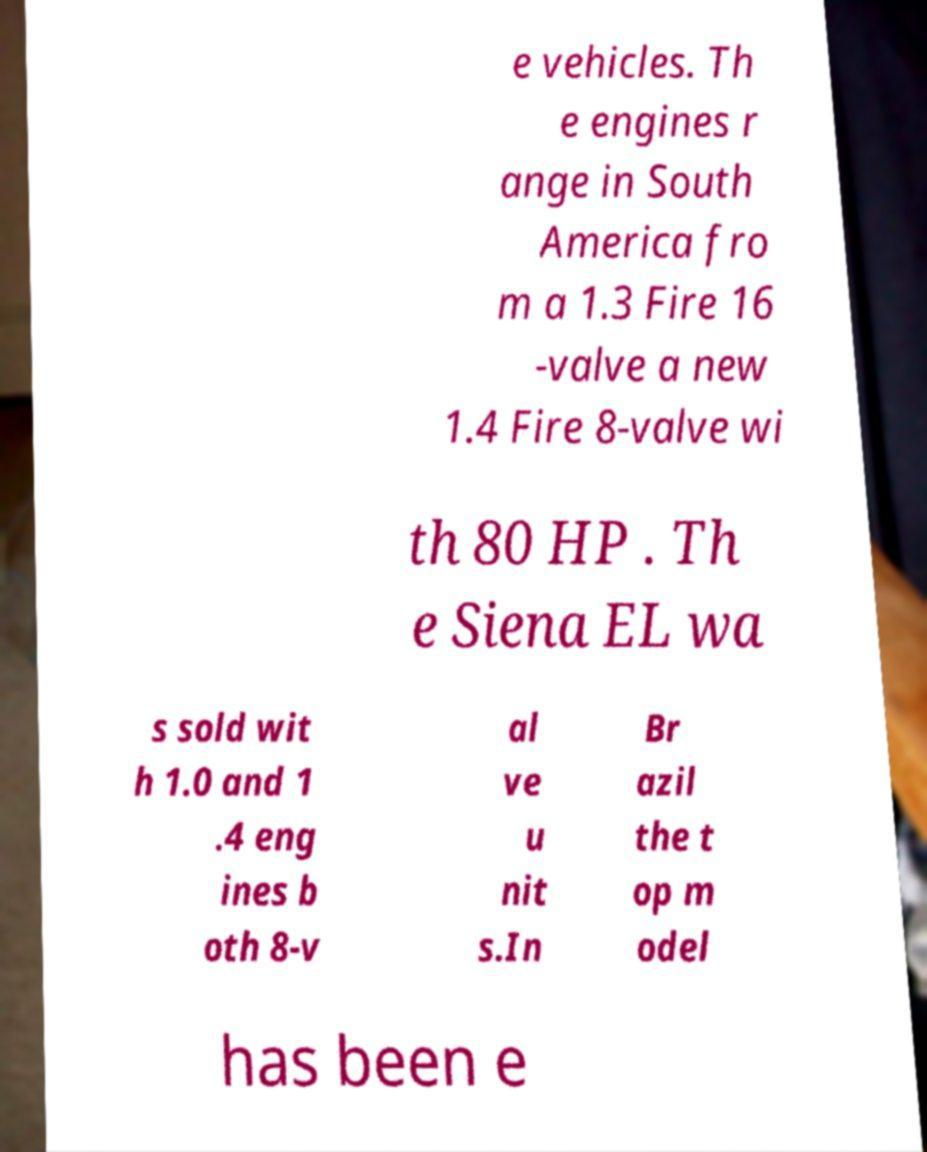I need the written content from this picture converted into text. Can you do that? e vehicles. Th e engines r ange in South America fro m a 1.3 Fire 16 -valve a new 1.4 Fire 8-valve wi th 80 HP . Th e Siena EL wa s sold wit h 1.0 and 1 .4 eng ines b oth 8-v al ve u nit s.In Br azil the t op m odel has been e 